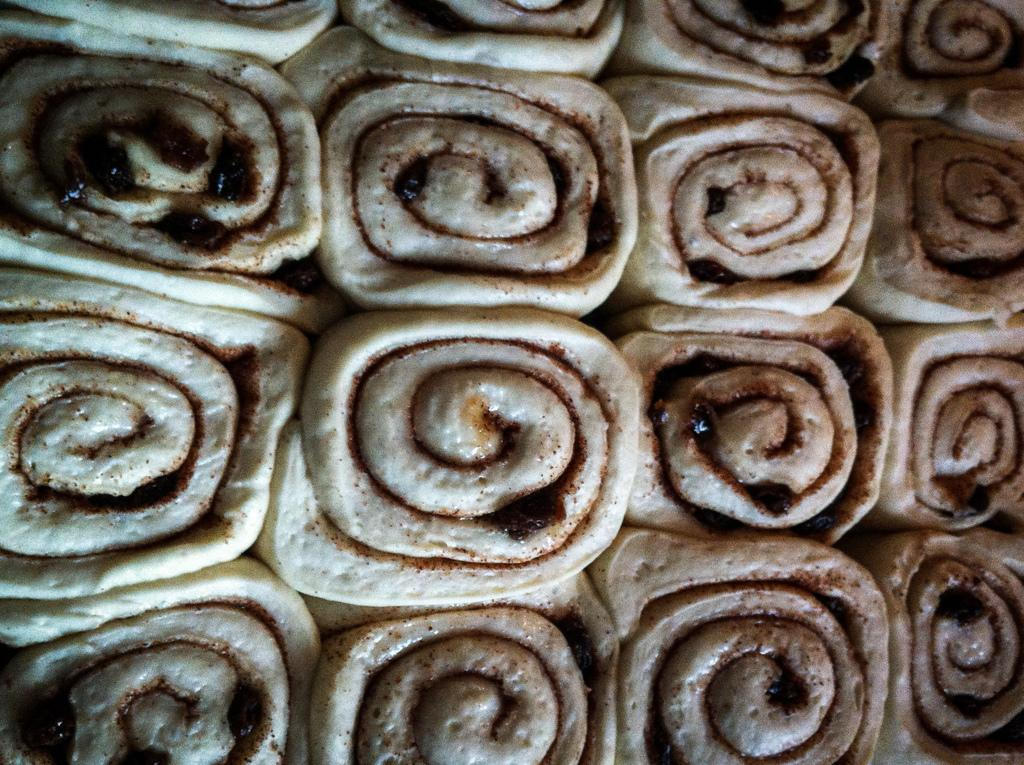What type of food is featured in the image? The image contains chocolate chip cinnamon rolls. Can you describe the appearance of the food? The chocolate chip cinnamon rolls have a swirled shape with chocolate chips and a cinnamon filling. What type of flowers can be seen growing in the cinnamon rolls? There are no flowers present in the image; it features chocolate chip cinnamon rolls. How many fingers are visible holding the cinnamon rolls in the image? There are no fingers visible in the image; it only shows the cinnamon rolls. 